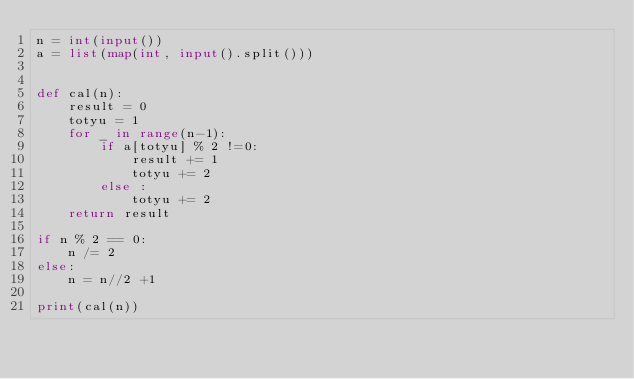<code> <loc_0><loc_0><loc_500><loc_500><_Python_>n = int(input())
a = list(map(int, input().split()))


def cal(n):
    result = 0
    totyu = 1
    for _ in range(n-1):
        if a[totyu] % 2 !=0:
            result += 1
            totyu += 2
        else :
            totyu += 2
    return result

if n % 2 == 0:
    n /= 2
else:
    n = n//2 +1 

print(cal(n))</code> 